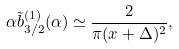<formula> <loc_0><loc_0><loc_500><loc_500>\alpha \tilde { b } ^ { ( 1 ) } _ { 3 / 2 } ( \alpha ) \simeq \frac { 2 } { \pi ( x + \Delta ) ^ { 2 } } ,</formula> 